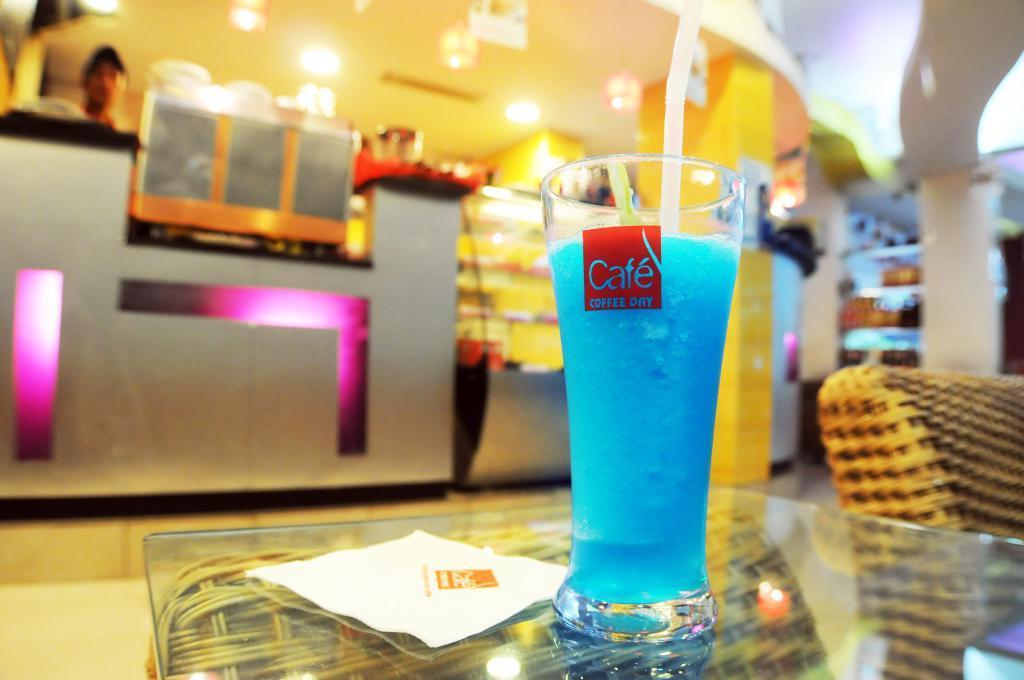Please provide a concise description of this image. This is an inside view. At the bottom of this image I can see glass table on which a tissue paper and a glass are placed. Beside this there is a chair. On the left side, I can see another table. At the back of it I can see a person. On the top there are some lights. In the background there is a rack and a pillar. 